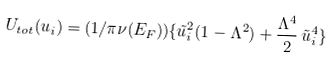Convert formula to latex. <formula><loc_0><loc_0><loc_500><loc_500>U _ { t o t } ( u _ { i } ) = ( 1 / \pi \nu ( E _ { F } ) ) \{ \tilde { u } _ { i } ^ { 2 } ( 1 - \Lambda ^ { 2 } ) + \frac { \Lambda ^ { 4 } } { 2 } \, \tilde { u } _ { i } ^ { 4 } \}</formula> 